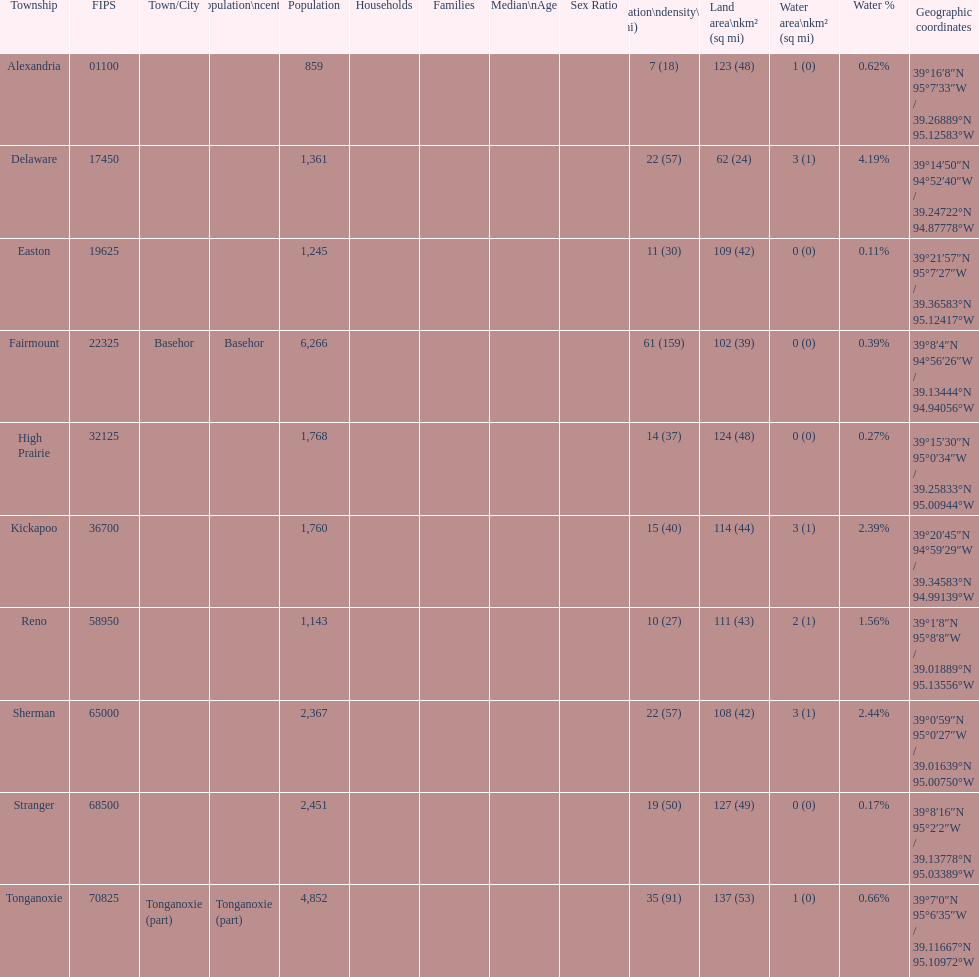Which township has the least land area? Delaware. 